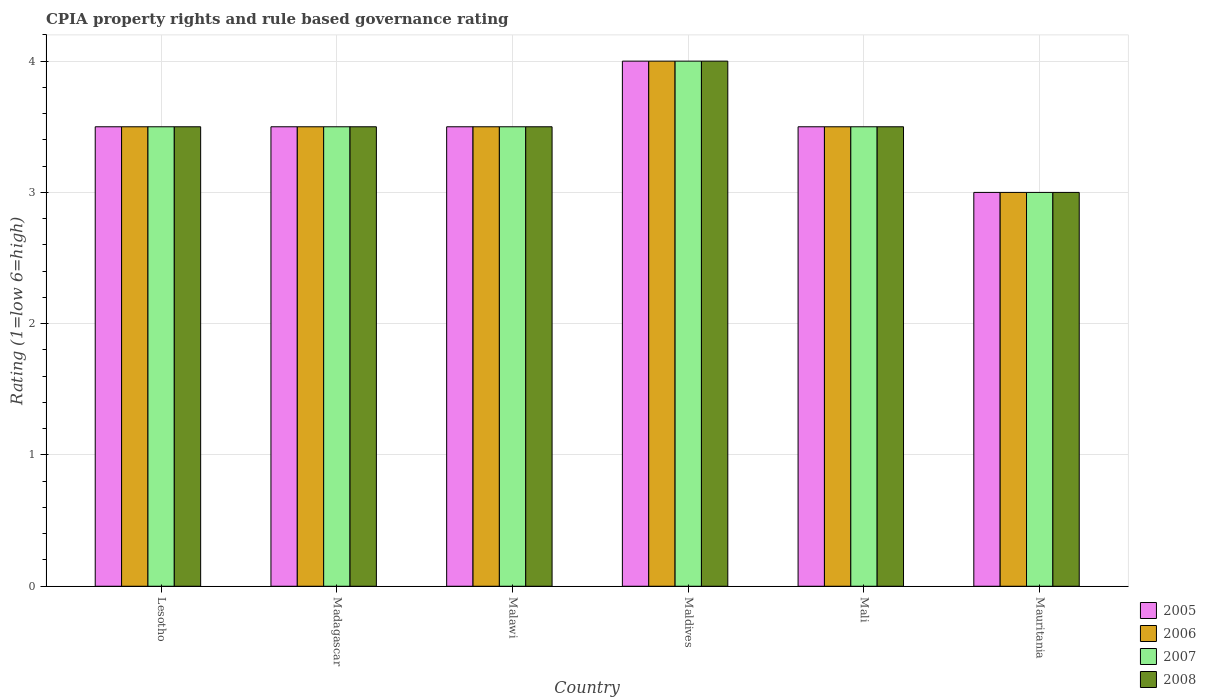Are the number of bars on each tick of the X-axis equal?
Give a very brief answer. Yes. How many bars are there on the 6th tick from the right?
Ensure brevity in your answer.  4. What is the label of the 1st group of bars from the left?
Your answer should be compact. Lesotho. In how many cases, is the number of bars for a given country not equal to the number of legend labels?
Ensure brevity in your answer.  0. What is the CPIA rating in 2007 in Lesotho?
Provide a short and direct response. 3.5. In which country was the CPIA rating in 2008 maximum?
Offer a terse response. Maldives. In which country was the CPIA rating in 2007 minimum?
Offer a terse response. Mauritania. What is the difference between the CPIA rating in 2008 in Madagascar and that in Mali?
Your answer should be very brief. 0. What is the difference between the CPIA rating in 2007 in Madagascar and the CPIA rating in 2008 in Maldives?
Your answer should be very brief. -0.5. What is the average CPIA rating in 2005 per country?
Your answer should be compact. 3.5. In how many countries, is the CPIA rating in 2006 greater than 3?
Your answer should be compact. 5. Is the difference between the CPIA rating in 2007 in Madagascar and Malawi greater than the difference between the CPIA rating in 2008 in Madagascar and Malawi?
Provide a succinct answer. No. What is the difference between the highest and the lowest CPIA rating in 2007?
Offer a very short reply. 1. Is the sum of the CPIA rating in 2006 in Lesotho and Madagascar greater than the maximum CPIA rating in 2005 across all countries?
Keep it short and to the point. Yes. Is it the case that in every country, the sum of the CPIA rating in 2008 and CPIA rating in 2005 is greater than the sum of CPIA rating in 2007 and CPIA rating in 2006?
Offer a very short reply. No. How many countries are there in the graph?
Ensure brevity in your answer.  6. Are the values on the major ticks of Y-axis written in scientific E-notation?
Give a very brief answer. No. Does the graph contain any zero values?
Keep it short and to the point. No. Does the graph contain grids?
Make the answer very short. Yes. Where does the legend appear in the graph?
Offer a very short reply. Bottom right. How many legend labels are there?
Offer a very short reply. 4. How are the legend labels stacked?
Offer a terse response. Vertical. What is the title of the graph?
Give a very brief answer. CPIA property rights and rule based governance rating. What is the Rating (1=low 6=high) in 2006 in Lesotho?
Offer a very short reply. 3.5. What is the Rating (1=low 6=high) in 2007 in Lesotho?
Ensure brevity in your answer.  3.5. What is the Rating (1=low 6=high) of 2005 in Madagascar?
Give a very brief answer. 3.5. What is the Rating (1=low 6=high) in 2007 in Madagascar?
Give a very brief answer. 3.5. What is the Rating (1=low 6=high) of 2005 in Malawi?
Your answer should be very brief. 3.5. What is the Rating (1=low 6=high) of 2006 in Malawi?
Make the answer very short. 3.5. What is the Rating (1=low 6=high) of 2007 in Malawi?
Offer a very short reply. 3.5. What is the Rating (1=low 6=high) in 2006 in Maldives?
Provide a short and direct response. 4. What is the Rating (1=low 6=high) in 2008 in Maldives?
Offer a terse response. 4. What is the Rating (1=low 6=high) of 2006 in Mali?
Ensure brevity in your answer.  3.5. What is the Rating (1=low 6=high) in 2006 in Mauritania?
Your answer should be very brief. 3. Across all countries, what is the maximum Rating (1=low 6=high) of 2006?
Your response must be concise. 4. Across all countries, what is the maximum Rating (1=low 6=high) in 2007?
Give a very brief answer. 4. Across all countries, what is the minimum Rating (1=low 6=high) in 2007?
Your response must be concise. 3. What is the difference between the Rating (1=low 6=high) of 2008 in Lesotho and that in Madagascar?
Your answer should be very brief. 0. What is the difference between the Rating (1=low 6=high) in 2006 in Lesotho and that in Malawi?
Your answer should be compact. 0. What is the difference between the Rating (1=low 6=high) in 2006 in Lesotho and that in Maldives?
Ensure brevity in your answer.  -0.5. What is the difference between the Rating (1=low 6=high) in 2008 in Lesotho and that in Maldives?
Give a very brief answer. -0.5. What is the difference between the Rating (1=low 6=high) in 2008 in Lesotho and that in Mali?
Provide a succinct answer. 0. What is the difference between the Rating (1=low 6=high) of 2006 in Lesotho and that in Mauritania?
Provide a succinct answer. 0.5. What is the difference between the Rating (1=low 6=high) in 2007 in Lesotho and that in Mauritania?
Make the answer very short. 0.5. What is the difference between the Rating (1=low 6=high) of 2008 in Lesotho and that in Mauritania?
Keep it short and to the point. 0.5. What is the difference between the Rating (1=low 6=high) of 2005 in Madagascar and that in Malawi?
Make the answer very short. 0. What is the difference between the Rating (1=low 6=high) in 2007 in Madagascar and that in Malawi?
Make the answer very short. 0. What is the difference between the Rating (1=low 6=high) in 2008 in Madagascar and that in Malawi?
Offer a very short reply. 0. What is the difference between the Rating (1=low 6=high) in 2005 in Madagascar and that in Maldives?
Offer a very short reply. -0.5. What is the difference between the Rating (1=low 6=high) of 2008 in Madagascar and that in Maldives?
Provide a short and direct response. -0.5. What is the difference between the Rating (1=low 6=high) of 2006 in Madagascar and that in Mali?
Provide a succinct answer. 0. What is the difference between the Rating (1=low 6=high) of 2008 in Madagascar and that in Mali?
Keep it short and to the point. 0. What is the difference between the Rating (1=low 6=high) of 2005 in Madagascar and that in Mauritania?
Your response must be concise. 0.5. What is the difference between the Rating (1=low 6=high) in 2006 in Madagascar and that in Mauritania?
Offer a very short reply. 0.5. What is the difference between the Rating (1=low 6=high) of 2007 in Madagascar and that in Mauritania?
Provide a succinct answer. 0.5. What is the difference between the Rating (1=low 6=high) of 2008 in Madagascar and that in Mauritania?
Provide a succinct answer. 0.5. What is the difference between the Rating (1=low 6=high) in 2005 in Malawi and that in Maldives?
Ensure brevity in your answer.  -0.5. What is the difference between the Rating (1=low 6=high) of 2006 in Malawi and that in Maldives?
Your answer should be compact. -0.5. What is the difference between the Rating (1=low 6=high) of 2007 in Malawi and that in Mali?
Offer a very short reply. 0. What is the difference between the Rating (1=low 6=high) of 2005 in Malawi and that in Mauritania?
Your response must be concise. 0.5. What is the difference between the Rating (1=low 6=high) in 2007 in Malawi and that in Mauritania?
Offer a very short reply. 0.5. What is the difference between the Rating (1=low 6=high) in 2008 in Malawi and that in Mauritania?
Ensure brevity in your answer.  0.5. What is the difference between the Rating (1=low 6=high) in 2005 in Maldives and that in Mali?
Offer a very short reply. 0.5. What is the difference between the Rating (1=low 6=high) of 2008 in Maldives and that in Mali?
Provide a short and direct response. 0.5. What is the difference between the Rating (1=low 6=high) of 2005 in Maldives and that in Mauritania?
Offer a very short reply. 1. What is the difference between the Rating (1=low 6=high) in 2007 in Maldives and that in Mauritania?
Your answer should be compact. 1. What is the difference between the Rating (1=low 6=high) in 2005 in Mali and that in Mauritania?
Your response must be concise. 0.5. What is the difference between the Rating (1=low 6=high) of 2005 in Lesotho and the Rating (1=low 6=high) of 2007 in Madagascar?
Offer a terse response. 0. What is the difference between the Rating (1=low 6=high) of 2005 in Lesotho and the Rating (1=low 6=high) of 2008 in Madagascar?
Your answer should be compact. 0. What is the difference between the Rating (1=low 6=high) in 2006 in Lesotho and the Rating (1=low 6=high) in 2007 in Madagascar?
Offer a very short reply. 0. What is the difference between the Rating (1=low 6=high) of 2006 in Lesotho and the Rating (1=low 6=high) of 2008 in Madagascar?
Make the answer very short. 0. What is the difference between the Rating (1=low 6=high) of 2007 in Lesotho and the Rating (1=low 6=high) of 2008 in Madagascar?
Ensure brevity in your answer.  0. What is the difference between the Rating (1=low 6=high) in 2005 in Lesotho and the Rating (1=low 6=high) in 2006 in Malawi?
Your answer should be compact. 0. What is the difference between the Rating (1=low 6=high) in 2005 in Lesotho and the Rating (1=low 6=high) in 2007 in Malawi?
Keep it short and to the point. 0. What is the difference between the Rating (1=low 6=high) in 2006 in Lesotho and the Rating (1=low 6=high) in 2007 in Malawi?
Provide a succinct answer. 0. What is the difference between the Rating (1=low 6=high) in 2007 in Lesotho and the Rating (1=low 6=high) in 2008 in Malawi?
Ensure brevity in your answer.  0. What is the difference between the Rating (1=low 6=high) of 2005 in Lesotho and the Rating (1=low 6=high) of 2007 in Maldives?
Give a very brief answer. -0.5. What is the difference between the Rating (1=low 6=high) of 2005 in Lesotho and the Rating (1=low 6=high) of 2008 in Maldives?
Your answer should be compact. -0.5. What is the difference between the Rating (1=low 6=high) of 2006 in Lesotho and the Rating (1=low 6=high) of 2007 in Maldives?
Your answer should be very brief. -0.5. What is the difference between the Rating (1=low 6=high) in 2006 in Lesotho and the Rating (1=low 6=high) in 2008 in Maldives?
Your answer should be compact. -0.5. What is the difference between the Rating (1=low 6=high) in 2007 in Lesotho and the Rating (1=low 6=high) in 2008 in Maldives?
Offer a terse response. -0.5. What is the difference between the Rating (1=low 6=high) of 2005 in Lesotho and the Rating (1=low 6=high) of 2006 in Mali?
Your response must be concise. 0. What is the difference between the Rating (1=low 6=high) in 2005 in Lesotho and the Rating (1=low 6=high) in 2008 in Mali?
Offer a terse response. 0. What is the difference between the Rating (1=low 6=high) of 2006 in Lesotho and the Rating (1=low 6=high) of 2007 in Mali?
Make the answer very short. 0. What is the difference between the Rating (1=low 6=high) in 2006 in Lesotho and the Rating (1=low 6=high) in 2008 in Mali?
Provide a succinct answer. 0. What is the difference between the Rating (1=low 6=high) in 2007 in Lesotho and the Rating (1=low 6=high) in 2008 in Mali?
Your answer should be compact. 0. What is the difference between the Rating (1=low 6=high) in 2005 in Lesotho and the Rating (1=low 6=high) in 2007 in Mauritania?
Keep it short and to the point. 0.5. What is the difference between the Rating (1=low 6=high) in 2006 in Lesotho and the Rating (1=low 6=high) in 2007 in Mauritania?
Give a very brief answer. 0.5. What is the difference between the Rating (1=low 6=high) of 2006 in Lesotho and the Rating (1=low 6=high) of 2008 in Mauritania?
Make the answer very short. 0.5. What is the difference between the Rating (1=low 6=high) of 2005 in Madagascar and the Rating (1=low 6=high) of 2006 in Malawi?
Keep it short and to the point. 0. What is the difference between the Rating (1=low 6=high) of 2005 in Madagascar and the Rating (1=low 6=high) of 2007 in Malawi?
Provide a short and direct response. 0. What is the difference between the Rating (1=low 6=high) in 2006 in Madagascar and the Rating (1=low 6=high) in 2007 in Malawi?
Offer a terse response. 0. What is the difference between the Rating (1=low 6=high) of 2007 in Madagascar and the Rating (1=low 6=high) of 2008 in Malawi?
Offer a very short reply. 0. What is the difference between the Rating (1=low 6=high) of 2005 in Madagascar and the Rating (1=low 6=high) of 2006 in Maldives?
Keep it short and to the point. -0.5. What is the difference between the Rating (1=low 6=high) of 2005 in Madagascar and the Rating (1=low 6=high) of 2007 in Maldives?
Your response must be concise. -0.5. What is the difference between the Rating (1=low 6=high) in 2005 in Madagascar and the Rating (1=low 6=high) in 2008 in Maldives?
Keep it short and to the point. -0.5. What is the difference between the Rating (1=low 6=high) of 2006 in Madagascar and the Rating (1=low 6=high) of 2007 in Maldives?
Keep it short and to the point. -0.5. What is the difference between the Rating (1=low 6=high) in 2006 in Madagascar and the Rating (1=low 6=high) in 2008 in Maldives?
Offer a very short reply. -0.5. What is the difference between the Rating (1=low 6=high) of 2005 in Madagascar and the Rating (1=low 6=high) of 2006 in Mali?
Offer a terse response. 0. What is the difference between the Rating (1=low 6=high) in 2005 in Madagascar and the Rating (1=low 6=high) in 2007 in Mali?
Your response must be concise. 0. What is the difference between the Rating (1=low 6=high) in 2005 in Madagascar and the Rating (1=low 6=high) in 2008 in Mali?
Offer a terse response. 0. What is the difference between the Rating (1=low 6=high) of 2006 in Madagascar and the Rating (1=low 6=high) of 2007 in Mali?
Your response must be concise. 0. What is the difference between the Rating (1=low 6=high) of 2006 in Madagascar and the Rating (1=low 6=high) of 2008 in Mali?
Offer a very short reply. 0. What is the difference between the Rating (1=low 6=high) in 2005 in Madagascar and the Rating (1=low 6=high) in 2008 in Mauritania?
Provide a succinct answer. 0.5. What is the difference between the Rating (1=low 6=high) of 2006 in Madagascar and the Rating (1=low 6=high) of 2007 in Mauritania?
Ensure brevity in your answer.  0.5. What is the difference between the Rating (1=low 6=high) of 2007 in Madagascar and the Rating (1=low 6=high) of 2008 in Mauritania?
Your answer should be very brief. 0.5. What is the difference between the Rating (1=low 6=high) in 2006 in Malawi and the Rating (1=low 6=high) in 2007 in Maldives?
Give a very brief answer. -0.5. What is the difference between the Rating (1=low 6=high) of 2006 in Malawi and the Rating (1=low 6=high) of 2008 in Maldives?
Your response must be concise. -0.5. What is the difference between the Rating (1=low 6=high) in 2007 in Malawi and the Rating (1=low 6=high) in 2008 in Maldives?
Your answer should be very brief. -0.5. What is the difference between the Rating (1=low 6=high) of 2005 in Malawi and the Rating (1=low 6=high) of 2006 in Mali?
Give a very brief answer. 0. What is the difference between the Rating (1=low 6=high) of 2005 in Malawi and the Rating (1=low 6=high) of 2007 in Mali?
Keep it short and to the point. 0. What is the difference between the Rating (1=low 6=high) in 2006 in Malawi and the Rating (1=low 6=high) in 2008 in Mali?
Keep it short and to the point. 0. What is the difference between the Rating (1=low 6=high) of 2007 in Malawi and the Rating (1=low 6=high) of 2008 in Mali?
Provide a short and direct response. 0. What is the difference between the Rating (1=low 6=high) of 2005 in Malawi and the Rating (1=low 6=high) of 2006 in Mauritania?
Offer a terse response. 0.5. What is the difference between the Rating (1=low 6=high) in 2005 in Malawi and the Rating (1=low 6=high) in 2007 in Mauritania?
Give a very brief answer. 0.5. What is the difference between the Rating (1=low 6=high) in 2006 in Malawi and the Rating (1=low 6=high) in 2007 in Mauritania?
Your answer should be compact. 0.5. What is the difference between the Rating (1=low 6=high) of 2006 in Maldives and the Rating (1=low 6=high) of 2007 in Mali?
Your answer should be very brief. 0.5. What is the difference between the Rating (1=low 6=high) in 2005 in Maldives and the Rating (1=low 6=high) in 2006 in Mauritania?
Your answer should be compact. 1. What is the difference between the Rating (1=low 6=high) in 2005 in Maldives and the Rating (1=low 6=high) in 2007 in Mauritania?
Ensure brevity in your answer.  1. What is the difference between the Rating (1=low 6=high) of 2006 in Mali and the Rating (1=low 6=high) of 2007 in Mauritania?
Your answer should be very brief. 0.5. What is the difference between the Rating (1=low 6=high) of 2007 in Mali and the Rating (1=low 6=high) of 2008 in Mauritania?
Provide a succinct answer. 0.5. What is the average Rating (1=low 6=high) of 2005 per country?
Your answer should be very brief. 3.5. What is the average Rating (1=low 6=high) of 2007 per country?
Your answer should be compact. 3.5. What is the average Rating (1=low 6=high) of 2008 per country?
Provide a short and direct response. 3.5. What is the difference between the Rating (1=low 6=high) of 2005 and Rating (1=low 6=high) of 2006 in Lesotho?
Your response must be concise. 0. What is the difference between the Rating (1=low 6=high) in 2005 and Rating (1=low 6=high) in 2007 in Lesotho?
Provide a succinct answer. 0. What is the difference between the Rating (1=low 6=high) of 2005 and Rating (1=low 6=high) of 2008 in Lesotho?
Give a very brief answer. 0. What is the difference between the Rating (1=low 6=high) of 2006 and Rating (1=low 6=high) of 2008 in Lesotho?
Your response must be concise. 0. What is the difference between the Rating (1=low 6=high) in 2005 and Rating (1=low 6=high) in 2007 in Madagascar?
Keep it short and to the point. 0. What is the difference between the Rating (1=low 6=high) of 2005 and Rating (1=low 6=high) of 2008 in Madagascar?
Give a very brief answer. 0. What is the difference between the Rating (1=low 6=high) of 2006 and Rating (1=low 6=high) of 2007 in Madagascar?
Provide a short and direct response. 0. What is the difference between the Rating (1=low 6=high) in 2006 and Rating (1=low 6=high) in 2008 in Madagascar?
Give a very brief answer. 0. What is the difference between the Rating (1=low 6=high) in 2005 and Rating (1=low 6=high) in 2006 in Malawi?
Your response must be concise. 0. What is the difference between the Rating (1=low 6=high) of 2005 and Rating (1=low 6=high) of 2007 in Malawi?
Your response must be concise. 0. What is the difference between the Rating (1=low 6=high) of 2007 and Rating (1=low 6=high) of 2008 in Malawi?
Your answer should be very brief. 0. What is the difference between the Rating (1=low 6=high) in 2005 and Rating (1=low 6=high) in 2007 in Maldives?
Offer a terse response. 0. What is the difference between the Rating (1=low 6=high) of 2005 and Rating (1=low 6=high) of 2008 in Maldives?
Your response must be concise. 0. What is the difference between the Rating (1=low 6=high) of 2006 and Rating (1=low 6=high) of 2007 in Maldives?
Offer a terse response. 0. What is the difference between the Rating (1=low 6=high) of 2006 and Rating (1=low 6=high) of 2008 in Maldives?
Offer a very short reply. 0. What is the difference between the Rating (1=low 6=high) in 2005 and Rating (1=low 6=high) in 2006 in Mali?
Your answer should be very brief. 0. What is the difference between the Rating (1=low 6=high) in 2006 and Rating (1=low 6=high) in 2007 in Mali?
Your answer should be compact. 0. What is the difference between the Rating (1=low 6=high) of 2005 and Rating (1=low 6=high) of 2006 in Mauritania?
Offer a terse response. 0. What is the difference between the Rating (1=low 6=high) in 2006 and Rating (1=low 6=high) in 2007 in Mauritania?
Keep it short and to the point. 0. What is the difference between the Rating (1=low 6=high) in 2007 and Rating (1=low 6=high) in 2008 in Mauritania?
Offer a terse response. 0. What is the ratio of the Rating (1=low 6=high) in 2007 in Lesotho to that in Madagascar?
Provide a succinct answer. 1. What is the ratio of the Rating (1=low 6=high) of 2005 in Lesotho to that in Malawi?
Give a very brief answer. 1. What is the ratio of the Rating (1=low 6=high) of 2007 in Lesotho to that in Malawi?
Your answer should be compact. 1. What is the ratio of the Rating (1=low 6=high) of 2008 in Lesotho to that in Malawi?
Your answer should be very brief. 1. What is the ratio of the Rating (1=low 6=high) of 2006 in Lesotho to that in Maldives?
Offer a very short reply. 0.88. What is the ratio of the Rating (1=low 6=high) in 2007 in Lesotho to that in Maldives?
Ensure brevity in your answer.  0.88. What is the ratio of the Rating (1=low 6=high) of 2008 in Lesotho to that in Maldives?
Provide a short and direct response. 0.88. What is the ratio of the Rating (1=low 6=high) of 2006 in Lesotho to that in Mali?
Your answer should be compact. 1. What is the ratio of the Rating (1=low 6=high) in 2008 in Lesotho to that in Mauritania?
Provide a succinct answer. 1.17. What is the ratio of the Rating (1=low 6=high) of 2005 in Madagascar to that in Malawi?
Offer a very short reply. 1. What is the ratio of the Rating (1=low 6=high) of 2006 in Madagascar to that in Malawi?
Keep it short and to the point. 1. What is the ratio of the Rating (1=low 6=high) in 2007 in Madagascar to that in Malawi?
Give a very brief answer. 1. What is the ratio of the Rating (1=low 6=high) in 2005 in Madagascar to that in Maldives?
Your answer should be compact. 0.88. What is the ratio of the Rating (1=low 6=high) of 2006 in Madagascar to that in Maldives?
Ensure brevity in your answer.  0.88. What is the ratio of the Rating (1=low 6=high) of 2007 in Madagascar to that in Maldives?
Make the answer very short. 0.88. What is the ratio of the Rating (1=low 6=high) of 2007 in Madagascar to that in Mali?
Provide a succinct answer. 1. What is the ratio of the Rating (1=low 6=high) in 2005 in Madagascar to that in Mauritania?
Provide a succinct answer. 1.17. What is the ratio of the Rating (1=low 6=high) of 2006 in Madagascar to that in Mauritania?
Keep it short and to the point. 1.17. What is the ratio of the Rating (1=low 6=high) in 2007 in Madagascar to that in Mauritania?
Offer a very short reply. 1.17. What is the ratio of the Rating (1=low 6=high) in 2005 in Malawi to that in Maldives?
Ensure brevity in your answer.  0.88. What is the ratio of the Rating (1=low 6=high) in 2006 in Malawi to that in Maldives?
Make the answer very short. 0.88. What is the ratio of the Rating (1=low 6=high) in 2008 in Malawi to that in Maldives?
Make the answer very short. 0.88. What is the ratio of the Rating (1=low 6=high) in 2006 in Malawi to that in Mauritania?
Offer a terse response. 1.17. What is the ratio of the Rating (1=low 6=high) in 2005 in Maldives to that in Mali?
Your response must be concise. 1.14. What is the ratio of the Rating (1=low 6=high) in 2007 in Maldives to that in Mali?
Provide a short and direct response. 1.14. What is the ratio of the Rating (1=low 6=high) of 2005 in Maldives to that in Mauritania?
Your response must be concise. 1.33. What is the ratio of the Rating (1=low 6=high) of 2008 in Maldives to that in Mauritania?
Provide a short and direct response. 1.33. What is the ratio of the Rating (1=low 6=high) of 2006 in Mali to that in Mauritania?
Your answer should be compact. 1.17. What is the ratio of the Rating (1=low 6=high) in 2007 in Mali to that in Mauritania?
Your response must be concise. 1.17. What is the ratio of the Rating (1=low 6=high) of 2008 in Mali to that in Mauritania?
Offer a very short reply. 1.17. What is the difference between the highest and the second highest Rating (1=low 6=high) of 2006?
Provide a succinct answer. 0.5. What is the difference between the highest and the second highest Rating (1=low 6=high) in 2007?
Offer a very short reply. 0.5. What is the difference between the highest and the second highest Rating (1=low 6=high) of 2008?
Provide a succinct answer. 0.5. What is the difference between the highest and the lowest Rating (1=low 6=high) in 2005?
Keep it short and to the point. 1. What is the difference between the highest and the lowest Rating (1=low 6=high) in 2006?
Give a very brief answer. 1. What is the difference between the highest and the lowest Rating (1=low 6=high) in 2007?
Ensure brevity in your answer.  1. 